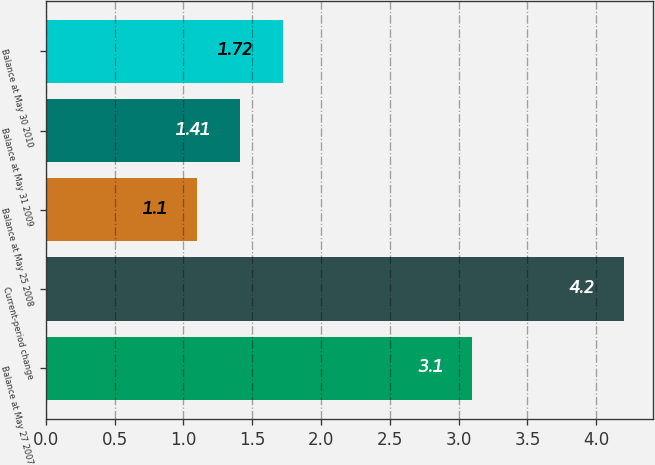Convert chart to OTSL. <chart><loc_0><loc_0><loc_500><loc_500><bar_chart><fcel>Balance at May 27 2007<fcel>Current-period change<fcel>Balance at May 25 2008<fcel>Balance at May 31 2009<fcel>Balance at May 30 2010<nl><fcel>3.1<fcel>4.2<fcel>1.1<fcel>1.41<fcel>1.72<nl></chart> 